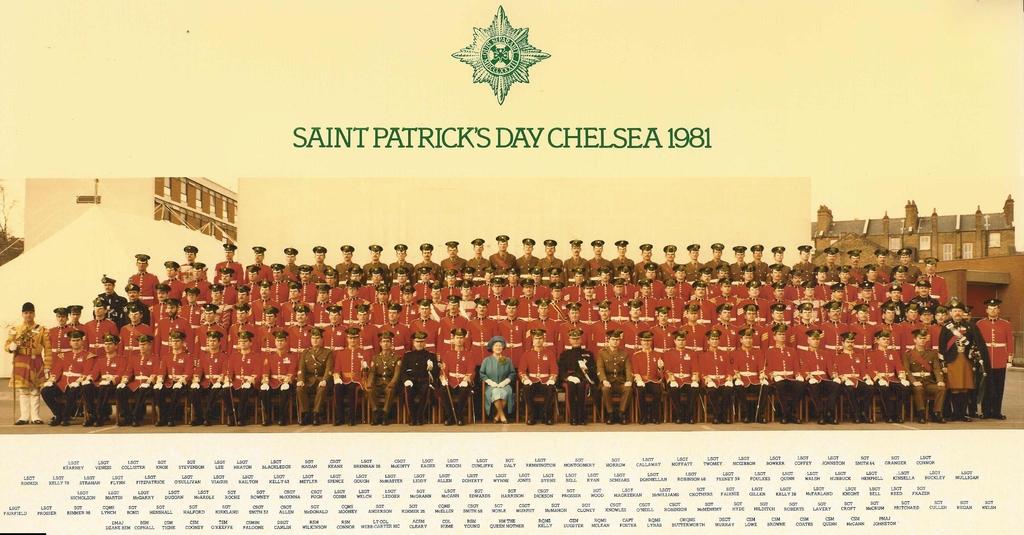What year is this picture taken?
Keep it short and to the point. 1981. What day was this taken?
Give a very brief answer. Saint patrick's day. 